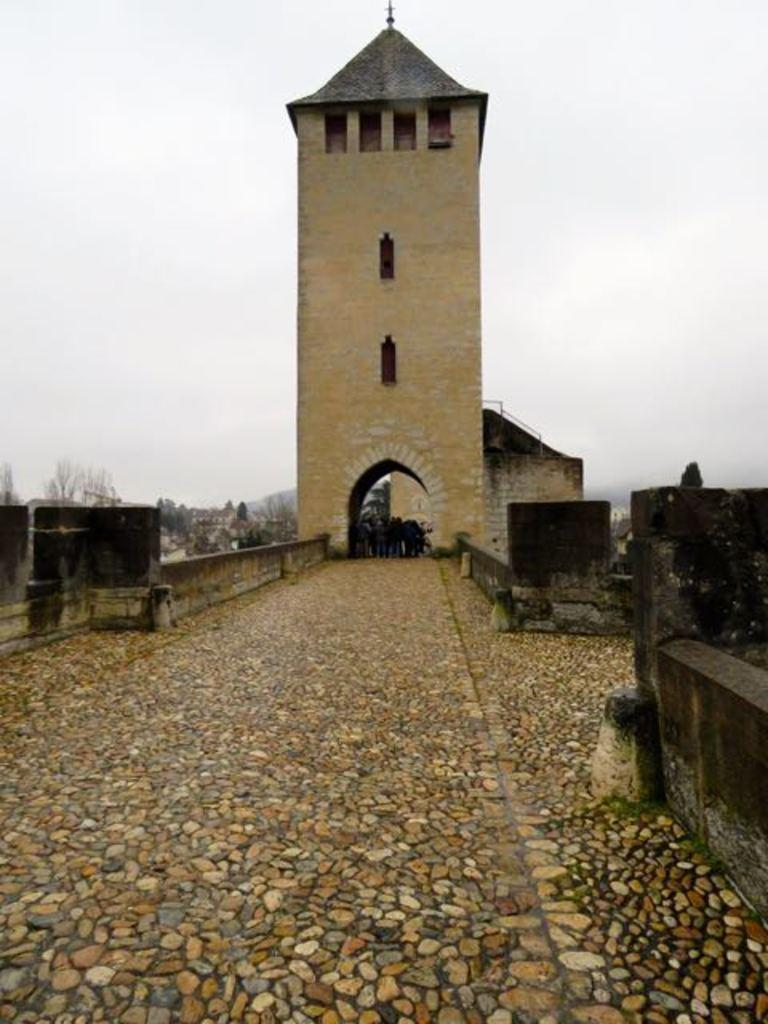What is the main structure in the image? There is a building tower in the image. What is located near the building tower? There is a wall in the image. What else can be seen in the image besides the building tower and wall? There are other objects in the image. What can be seen in the background of the image? There are trees and the sky visible in the background of the image. What type of sheet is covering the stars in the image? There are no stars or sheets present in the image. 